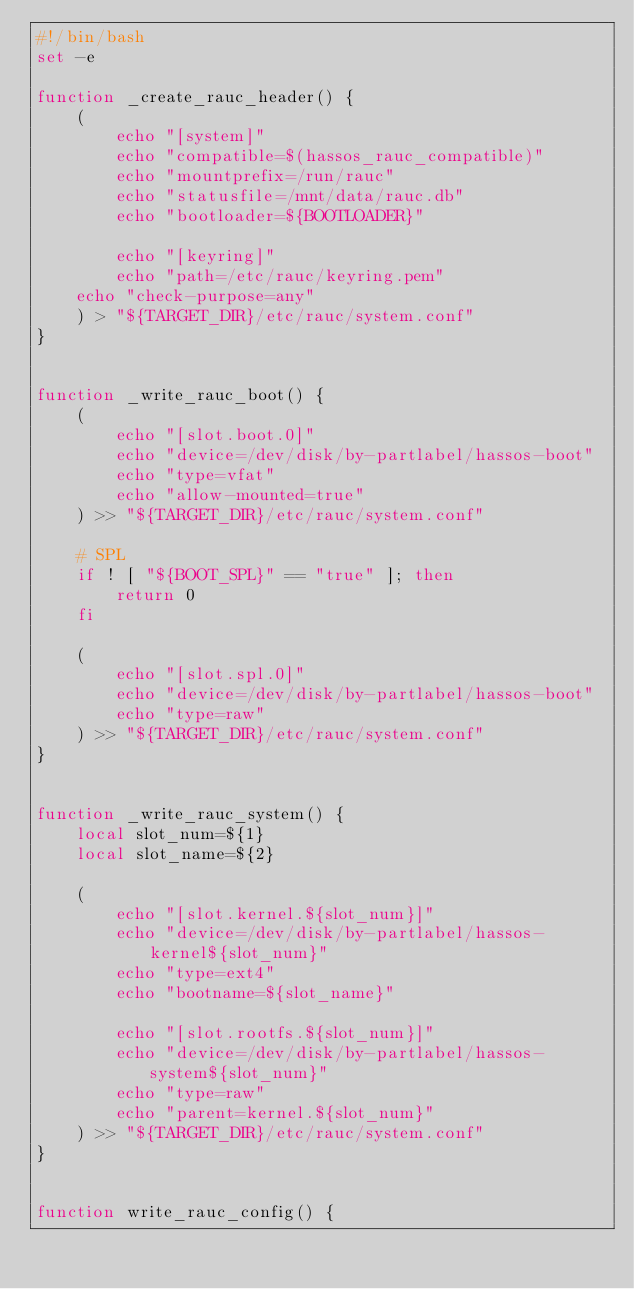<code> <loc_0><loc_0><loc_500><loc_500><_Bash_>#!/bin/bash
set -e

function _create_rauc_header() {
    (
        echo "[system]"
        echo "compatible=$(hassos_rauc_compatible)"
        echo "mountprefix=/run/rauc"
        echo "statusfile=/mnt/data/rauc.db"
        echo "bootloader=${BOOTLOADER}"

        echo "[keyring]"
        echo "path=/etc/rauc/keyring.pem"
	echo "check-purpose=any"
    ) > "${TARGET_DIR}/etc/rauc/system.conf"
}


function _write_rauc_boot() {
    (
        echo "[slot.boot.0]"
        echo "device=/dev/disk/by-partlabel/hassos-boot"
        echo "type=vfat"
        echo "allow-mounted=true"
    ) >> "${TARGET_DIR}/etc/rauc/system.conf"

    # SPL
    if ! [ "${BOOT_SPL}" == "true" ]; then
        return 0
    fi

    (
        echo "[slot.spl.0]"
        echo "device=/dev/disk/by-partlabel/hassos-boot"
        echo "type=raw"
    ) >> "${TARGET_DIR}/etc/rauc/system.conf"
}


function _write_rauc_system() {
    local slot_num=${1}
    local slot_name=${2}

    (
        echo "[slot.kernel.${slot_num}]"
        echo "device=/dev/disk/by-partlabel/hassos-kernel${slot_num}"
        echo "type=ext4"
        echo "bootname=${slot_name}"

        echo "[slot.rootfs.${slot_num}]"
        echo "device=/dev/disk/by-partlabel/hassos-system${slot_num}"
        echo "type=raw"
        echo "parent=kernel.${slot_num}"
    ) >> "${TARGET_DIR}/etc/rauc/system.conf"
}


function write_rauc_config() {</code> 